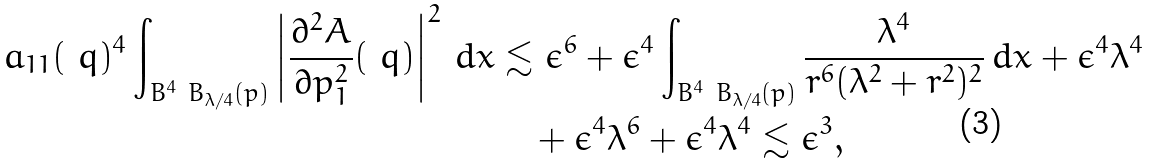<formula> <loc_0><loc_0><loc_500><loc_500>a _ { 1 1 } ( \ q ) ^ { 4 } \int _ { B ^ { 4 } \ B _ { \lambda / 4 } ( p ) } \left | \frac { \partial ^ { 2 } A } { \partial p _ { 1 } ^ { 2 } } ( \ q ) \right | ^ { 2 } \, d x & \lesssim \epsilon ^ { 6 } + \epsilon ^ { 4 } \int _ { B ^ { 4 } \ B _ { \lambda / 4 } ( p ) } \frac { \lambda ^ { 4 } } { r ^ { 6 } ( \lambda ^ { 2 } + r ^ { 2 } ) ^ { 2 } } \, d x + \epsilon ^ { 4 } \lambda ^ { 4 } \\ & \quad + \epsilon ^ { 4 } \lambda ^ { 6 } + \epsilon ^ { 4 } \lambda ^ { 4 } \lesssim \epsilon ^ { 3 } ,</formula> 